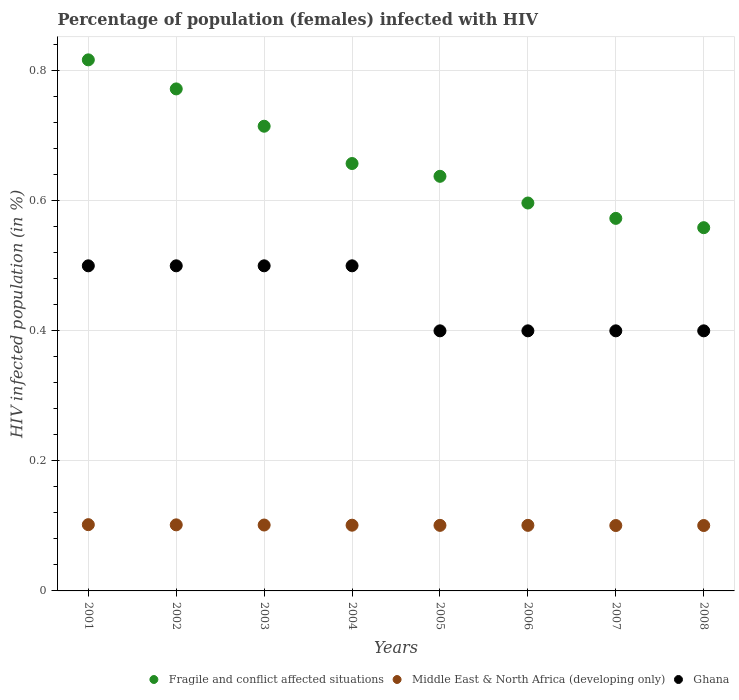What is the percentage of HIV infected female population in Ghana in 2003?
Your answer should be compact. 0.5. Across all years, what is the minimum percentage of HIV infected female population in Middle East & North Africa (developing only)?
Provide a succinct answer. 0.1. What is the total percentage of HIV infected female population in Middle East & North Africa (developing only) in the graph?
Keep it short and to the point. 0.81. What is the difference between the percentage of HIV infected female population in Middle East & North Africa (developing only) in 2003 and that in 2005?
Give a very brief answer. 0. What is the difference between the percentage of HIV infected female population in Middle East & North Africa (developing only) in 2002 and the percentage of HIV infected female population in Fragile and conflict affected situations in 2008?
Offer a terse response. -0.46. What is the average percentage of HIV infected female population in Fragile and conflict affected situations per year?
Offer a terse response. 0.67. In the year 2006, what is the difference between the percentage of HIV infected female population in Fragile and conflict affected situations and percentage of HIV infected female population in Middle East & North Africa (developing only)?
Keep it short and to the point. 0.5. In how many years, is the percentage of HIV infected female population in Middle East & North Africa (developing only) greater than 0.32 %?
Give a very brief answer. 0. What is the ratio of the percentage of HIV infected female population in Fragile and conflict affected situations in 2006 to that in 2008?
Your answer should be compact. 1.07. Is the percentage of HIV infected female population in Ghana in 2001 less than that in 2003?
Offer a terse response. No. What is the difference between the highest and the second highest percentage of HIV infected female population in Middle East & North Africa (developing only)?
Make the answer very short. 0. What is the difference between the highest and the lowest percentage of HIV infected female population in Middle East & North Africa (developing only)?
Make the answer very short. 0. In how many years, is the percentage of HIV infected female population in Fragile and conflict affected situations greater than the average percentage of HIV infected female population in Fragile and conflict affected situations taken over all years?
Ensure brevity in your answer.  3. Is the sum of the percentage of HIV infected female population in Fragile and conflict affected situations in 2005 and 2006 greater than the maximum percentage of HIV infected female population in Middle East & North Africa (developing only) across all years?
Make the answer very short. Yes. Does the percentage of HIV infected female population in Ghana monotonically increase over the years?
Your answer should be very brief. No. Is the percentage of HIV infected female population in Ghana strictly greater than the percentage of HIV infected female population in Middle East & North Africa (developing only) over the years?
Provide a succinct answer. Yes. Is the percentage of HIV infected female population in Fragile and conflict affected situations strictly less than the percentage of HIV infected female population in Middle East & North Africa (developing only) over the years?
Offer a very short reply. No. Does the graph contain any zero values?
Give a very brief answer. No. How many legend labels are there?
Make the answer very short. 3. How are the legend labels stacked?
Ensure brevity in your answer.  Horizontal. What is the title of the graph?
Offer a terse response. Percentage of population (females) infected with HIV. Does "Kazakhstan" appear as one of the legend labels in the graph?
Make the answer very short. No. What is the label or title of the Y-axis?
Your answer should be compact. HIV infected population (in %). What is the HIV infected population (in %) in Fragile and conflict affected situations in 2001?
Give a very brief answer. 0.82. What is the HIV infected population (in %) in Middle East & North Africa (developing only) in 2001?
Keep it short and to the point. 0.1. What is the HIV infected population (in %) of Ghana in 2001?
Offer a very short reply. 0.5. What is the HIV infected population (in %) of Fragile and conflict affected situations in 2002?
Ensure brevity in your answer.  0.77. What is the HIV infected population (in %) of Middle East & North Africa (developing only) in 2002?
Keep it short and to the point. 0.1. What is the HIV infected population (in %) in Fragile and conflict affected situations in 2003?
Your response must be concise. 0.71. What is the HIV infected population (in %) in Middle East & North Africa (developing only) in 2003?
Give a very brief answer. 0.1. What is the HIV infected population (in %) of Fragile and conflict affected situations in 2004?
Offer a terse response. 0.66. What is the HIV infected population (in %) in Middle East & North Africa (developing only) in 2004?
Provide a short and direct response. 0.1. What is the HIV infected population (in %) of Ghana in 2004?
Make the answer very short. 0.5. What is the HIV infected population (in %) of Fragile and conflict affected situations in 2005?
Your response must be concise. 0.64. What is the HIV infected population (in %) in Middle East & North Africa (developing only) in 2005?
Make the answer very short. 0.1. What is the HIV infected population (in %) in Ghana in 2005?
Ensure brevity in your answer.  0.4. What is the HIV infected population (in %) in Fragile and conflict affected situations in 2006?
Make the answer very short. 0.6. What is the HIV infected population (in %) in Middle East & North Africa (developing only) in 2006?
Your answer should be compact. 0.1. What is the HIV infected population (in %) of Fragile and conflict affected situations in 2007?
Make the answer very short. 0.57. What is the HIV infected population (in %) in Middle East & North Africa (developing only) in 2007?
Provide a short and direct response. 0.1. What is the HIV infected population (in %) of Ghana in 2007?
Make the answer very short. 0.4. What is the HIV infected population (in %) in Fragile and conflict affected situations in 2008?
Keep it short and to the point. 0.56. What is the HIV infected population (in %) of Middle East & North Africa (developing only) in 2008?
Offer a terse response. 0.1. Across all years, what is the maximum HIV infected population (in %) in Fragile and conflict affected situations?
Your answer should be compact. 0.82. Across all years, what is the maximum HIV infected population (in %) of Middle East & North Africa (developing only)?
Ensure brevity in your answer.  0.1. Across all years, what is the minimum HIV infected population (in %) of Fragile and conflict affected situations?
Your answer should be very brief. 0.56. Across all years, what is the minimum HIV infected population (in %) of Middle East & North Africa (developing only)?
Give a very brief answer. 0.1. Across all years, what is the minimum HIV infected population (in %) of Ghana?
Ensure brevity in your answer.  0.4. What is the total HIV infected population (in %) in Fragile and conflict affected situations in the graph?
Keep it short and to the point. 5.33. What is the total HIV infected population (in %) in Middle East & North Africa (developing only) in the graph?
Your response must be concise. 0.81. What is the difference between the HIV infected population (in %) of Fragile and conflict affected situations in 2001 and that in 2002?
Make the answer very short. 0.04. What is the difference between the HIV infected population (in %) of Middle East & North Africa (developing only) in 2001 and that in 2002?
Keep it short and to the point. 0. What is the difference between the HIV infected population (in %) in Fragile and conflict affected situations in 2001 and that in 2003?
Keep it short and to the point. 0.1. What is the difference between the HIV infected population (in %) in Fragile and conflict affected situations in 2001 and that in 2004?
Your response must be concise. 0.16. What is the difference between the HIV infected population (in %) of Middle East & North Africa (developing only) in 2001 and that in 2004?
Your answer should be compact. 0. What is the difference between the HIV infected population (in %) of Ghana in 2001 and that in 2004?
Your response must be concise. 0. What is the difference between the HIV infected population (in %) of Fragile and conflict affected situations in 2001 and that in 2005?
Offer a very short reply. 0.18. What is the difference between the HIV infected population (in %) of Middle East & North Africa (developing only) in 2001 and that in 2005?
Keep it short and to the point. 0. What is the difference between the HIV infected population (in %) of Fragile and conflict affected situations in 2001 and that in 2006?
Your answer should be very brief. 0.22. What is the difference between the HIV infected population (in %) in Middle East & North Africa (developing only) in 2001 and that in 2006?
Ensure brevity in your answer.  0. What is the difference between the HIV infected population (in %) in Ghana in 2001 and that in 2006?
Provide a succinct answer. 0.1. What is the difference between the HIV infected population (in %) of Fragile and conflict affected situations in 2001 and that in 2007?
Your answer should be compact. 0.24. What is the difference between the HIV infected population (in %) of Middle East & North Africa (developing only) in 2001 and that in 2007?
Your response must be concise. 0. What is the difference between the HIV infected population (in %) of Fragile and conflict affected situations in 2001 and that in 2008?
Give a very brief answer. 0.26. What is the difference between the HIV infected population (in %) of Middle East & North Africa (developing only) in 2001 and that in 2008?
Offer a very short reply. 0. What is the difference between the HIV infected population (in %) in Ghana in 2001 and that in 2008?
Provide a short and direct response. 0.1. What is the difference between the HIV infected population (in %) in Fragile and conflict affected situations in 2002 and that in 2003?
Offer a very short reply. 0.06. What is the difference between the HIV infected population (in %) of Middle East & North Africa (developing only) in 2002 and that in 2003?
Make the answer very short. 0. What is the difference between the HIV infected population (in %) in Fragile and conflict affected situations in 2002 and that in 2004?
Provide a succinct answer. 0.11. What is the difference between the HIV infected population (in %) in Middle East & North Africa (developing only) in 2002 and that in 2004?
Offer a terse response. 0. What is the difference between the HIV infected population (in %) in Fragile and conflict affected situations in 2002 and that in 2005?
Provide a short and direct response. 0.13. What is the difference between the HIV infected population (in %) in Middle East & North Africa (developing only) in 2002 and that in 2005?
Offer a terse response. 0. What is the difference between the HIV infected population (in %) in Fragile and conflict affected situations in 2002 and that in 2006?
Offer a very short reply. 0.18. What is the difference between the HIV infected population (in %) of Middle East & North Africa (developing only) in 2002 and that in 2006?
Ensure brevity in your answer.  0. What is the difference between the HIV infected population (in %) of Fragile and conflict affected situations in 2002 and that in 2007?
Provide a short and direct response. 0.2. What is the difference between the HIV infected population (in %) in Fragile and conflict affected situations in 2002 and that in 2008?
Keep it short and to the point. 0.21. What is the difference between the HIV infected population (in %) in Ghana in 2002 and that in 2008?
Offer a terse response. 0.1. What is the difference between the HIV infected population (in %) in Fragile and conflict affected situations in 2003 and that in 2004?
Your answer should be very brief. 0.06. What is the difference between the HIV infected population (in %) of Middle East & North Africa (developing only) in 2003 and that in 2004?
Offer a terse response. 0. What is the difference between the HIV infected population (in %) in Fragile and conflict affected situations in 2003 and that in 2005?
Provide a succinct answer. 0.08. What is the difference between the HIV infected population (in %) in Middle East & North Africa (developing only) in 2003 and that in 2005?
Your response must be concise. 0. What is the difference between the HIV infected population (in %) of Fragile and conflict affected situations in 2003 and that in 2006?
Your answer should be very brief. 0.12. What is the difference between the HIV infected population (in %) in Ghana in 2003 and that in 2006?
Provide a short and direct response. 0.1. What is the difference between the HIV infected population (in %) of Fragile and conflict affected situations in 2003 and that in 2007?
Offer a very short reply. 0.14. What is the difference between the HIV infected population (in %) of Middle East & North Africa (developing only) in 2003 and that in 2007?
Offer a terse response. 0. What is the difference between the HIV infected population (in %) of Fragile and conflict affected situations in 2003 and that in 2008?
Make the answer very short. 0.16. What is the difference between the HIV infected population (in %) of Middle East & North Africa (developing only) in 2003 and that in 2008?
Provide a succinct answer. 0. What is the difference between the HIV infected population (in %) in Fragile and conflict affected situations in 2004 and that in 2005?
Keep it short and to the point. 0.02. What is the difference between the HIV infected population (in %) in Middle East & North Africa (developing only) in 2004 and that in 2005?
Ensure brevity in your answer.  0. What is the difference between the HIV infected population (in %) of Ghana in 2004 and that in 2005?
Offer a very short reply. 0.1. What is the difference between the HIV infected population (in %) in Fragile and conflict affected situations in 2004 and that in 2006?
Keep it short and to the point. 0.06. What is the difference between the HIV infected population (in %) of Middle East & North Africa (developing only) in 2004 and that in 2006?
Provide a short and direct response. 0. What is the difference between the HIV infected population (in %) of Ghana in 2004 and that in 2006?
Give a very brief answer. 0.1. What is the difference between the HIV infected population (in %) of Fragile and conflict affected situations in 2004 and that in 2007?
Ensure brevity in your answer.  0.08. What is the difference between the HIV infected population (in %) in Middle East & North Africa (developing only) in 2004 and that in 2007?
Your answer should be very brief. 0. What is the difference between the HIV infected population (in %) of Ghana in 2004 and that in 2007?
Ensure brevity in your answer.  0.1. What is the difference between the HIV infected population (in %) in Fragile and conflict affected situations in 2004 and that in 2008?
Keep it short and to the point. 0.1. What is the difference between the HIV infected population (in %) of Ghana in 2004 and that in 2008?
Your answer should be very brief. 0.1. What is the difference between the HIV infected population (in %) of Fragile and conflict affected situations in 2005 and that in 2006?
Give a very brief answer. 0.04. What is the difference between the HIV infected population (in %) in Ghana in 2005 and that in 2006?
Make the answer very short. 0. What is the difference between the HIV infected population (in %) of Fragile and conflict affected situations in 2005 and that in 2007?
Provide a succinct answer. 0.06. What is the difference between the HIV infected population (in %) in Fragile and conflict affected situations in 2005 and that in 2008?
Provide a succinct answer. 0.08. What is the difference between the HIV infected population (in %) in Ghana in 2005 and that in 2008?
Make the answer very short. 0. What is the difference between the HIV infected population (in %) in Fragile and conflict affected situations in 2006 and that in 2007?
Ensure brevity in your answer.  0.02. What is the difference between the HIV infected population (in %) of Middle East & North Africa (developing only) in 2006 and that in 2007?
Ensure brevity in your answer.  0. What is the difference between the HIV infected population (in %) in Fragile and conflict affected situations in 2006 and that in 2008?
Ensure brevity in your answer.  0.04. What is the difference between the HIV infected population (in %) in Ghana in 2006 and that in 2008?
Make the answer very short. 0. What is the difference between the HIV infected population (in %) in Fragile and conflict affected situations in 2007 and that in 2008?
Make the answer very short. 0.01. What is the difference between the HIV infected population (in %) in Middle East & North Africa (developing only) in 2007 and that in 2008?
Your answer should be very brief. -0. What is the difference between the HIV infected population (in %) of Fragile and conflict affected situations in 2001 and the HIV infected population (in %) of Middle East & North Africa (developing only) in 2002?
Make the answer very short. 0.72. What is the difference between the HIV infected population (in %) in Fragile and conflict affected situations in 2001 and the HIV infected population (in %) in Ghana in 2002?
Keep it short and to the point. 0.32. What is the difference between the HIV infected population (in %) in Middle East & North Africa (developing only) in 2001 and the HIV infected population (in %) in Ghana in 2002?
Give a very brief answer. -0.4. What is the difference between the HIV infected population (in %) in Fragile and conflict affected situations in 2001 and the HIV infected population (in %) in Middle East & North Africa (developing only) in 2003?
Offer a very short reply. 0.72. What is the difference between the HIV infected population (in %) of Fragile and conflict affected situations in 2001 and the HIV infected population (in %) of Ghana in 2003?
Provide a succinct answer. 0.32. What is the difference between the HIV infected population (in %) in Middle East & North Africa (developing only) in 2001 and the HIV infected population (in %) in Ghana in 2003?
Offer a terse response. -0.4. What is the difference between the HIV infected population (in %) of Fragile and conflict affected situations in 2001 and the HIV infected population (in %) of Middle East & North Africa (developing only) in 2004?
Make the answer very short. 0.72. What is the difference between the HIV infected population (in %) in Fragile and conflict affected situations in 2001 and the HIV infected population (in %) in Ghana in 2004?
Offer a very short reply. 0.32. What is the difference between the HIV infected population (in %) in Middle East & North Africa (developing only) in 2001 and the HIV infected population (in %) in Ghana in 2004?
Give a very brief answer. -0.4. What is the difference between the HIV infected population (in %) of Fragile and conflict affected situations in 2001 and the HIV infected population (in %) of Middle East & North Africa (developing only) in 2005?
Your answer should be very brief. 0.72. What is the difference between the HIV infected population (in %) in Fragile and conflict affected situations in 2001 and the HIV infected population (in %) in Ghana in 2005?
Your answer should be compact. 0.42. What is the difference between the HIV infected population (in %) in Middle East & North Africa (developing only) in 2001 and the HIV infected population (in %) in Ghana in 2005?
Keep it short and to the point. -0.3. What is the difference between the HIV infected population (in %) of Fragile and conflict affected situations in 2001 and the HIV infected population (in %) of Middle East & North Africa (developing only) in 2006?
Offer a very short reply. 0.72. What is the difference between the HIV infected population (in %) in Fragile and conflict affected situations in 2001 and the HIV infected population (in %) in Ghana in 2006?
Provide a succinct answer. 0.42. What is the difference between the HIV infected population (in %) in Middle East & North Africa (developing only) in 2001 and the HIV infected population (in %) in Ghana in 2006?
Provide a short and direct response. -0.3. What is the difference between the HIV infected population (in %) in Fragile and conflict affected situations in 2001 and the HIV infected population (in %) in Middle East & North Africa (developing only) in 2007?
Provide a short and direct response. 0.72. What is the difference between the HIV infected population (in %) in Fragile and conflict affected situations in 2001 and the HIV infected population (in %) in Ghana in 2007?
Your answer should be compact. 0.42. What is the difference between the HIV infected population (in %) of Middle East & North Africa (developing only) in 2001 and the HIV infected population (in %) of Ghana in 2007?
Your answer should be compact. -0.3. What is the difference between the HIV infected population (in %) in Fragile and conflict affected situations in 2001 and the HIV infected population (in %) in Middle East & North Africa (developing only) in 2008?
Ensure brevity in your answer.  0.72. What is the difference between the HIV infected population (in %) in Fragile and conflict affected situations in 2001 and the HIV infected population (in %) in Ghana in 2008?
Provide a short and direct response. 0.42. What is the difference between the HIV infected population (in %) of Middle East & North Africa (developing only) in 2001 and the HIV infected population (in %) of Ghana in 2008?
Offer a terse response. -0.3. What is the difference between the HIV infected population (in %) in Fragile and conflict affected situations in 2002 and the HIV infected population (in %) in Middle East & North Africa (developing only) in 2003?
Provide a short and direct response. 0.67. What is the difference between the HIV infected population (in %) of Fragile and conflict affected situations in 2002 and the HIV infected population (in %) of Ghana in 2003?
Ensure brevity in your answer.  0.27. What is the difference between the HIV infected population (in %) of Middle East & North Africa (developing only) in 2002 and the HIV infected population (in %) of Ghana in 2003?
Your answer should be compact. -0.4. What is the difference between the HIV infected population (in %) in Fragile and conflict affected situations in 2002 and the HIV infected population (in %) in Middle East & North Africa (developing only) in 2004?
Give a very brief answer. 0.67. What is the difference between the HIV infected population (in %) of Fragile and conflict affected situations in 2002 and the HIV infected population (in %) of Ghana in 2004?
Offer a very short reply. 0.27. What is the difference between the HIV infected population (in %) in Middle East & North Africa (developing only) in 2002 and the HIV infected population (in %) in Ghana in 2004?
Offer a terse response. -0.4. What is the difference between the HIV infected population (in %) of Fragile and conflict affected situations in 2002 and the HIV infected population (in %) of Middle East & North Africa (developing only) in 2005?
Your answer should be compact. 0.67. What is the difference between the HIV infected population (in %) in Fragile and conflict affected situations in 2002 and the HIV infected population (in %) in Ghana in 2005?
Your answer should be very brief. 0.37. What is the difference between the HIV infected population (in %) of Middle East & North Africa (developing only) in 2002 and the HIV infected population (in %) of Ghana in 2005?
Keep it short and to the point. -0.3. What is the difference between the HIV infected population (in %) in Fragile and conflict affected situations in 2002 and the HIV infected population (in %) in Middle East & North Africa (developing only) in 2006?
Your answer should be very brief. 0.67. What is the difference between the HIV infected population (in %) of Fragile and conflict affected situations in 2002 and the HIV infected population (in %) of Ghana in 2006?
Provide a short and direct response. 0.37. What is the difference between the HIV infected population (in %) of Middle East & North Africa (developing only) in 2002 and the HIV infected population (in %) of Ghana in 2006?
Give a very brief answer. -0.3. What is the difference between the HIV infected population (in %) in Fragile and conflict affected situations in 2002 and the HIV infected population (in %) in Middle East & North Africa (developing only) in 2007?
Make the answer very short. 0.67. What is the difference between the HIV infected population (in %) in Fragile and conflict affected situations in 2002 and the HIV infected population (in %) in Ghana in 2007?
Provide a succinct answer. 0.37. What is the difference between the HIV infected population (in %) of Middle East & North Africa (developing only) in 2002 and the HIV infected population (in %) of Ghana in 2007?
Offer a terse response. -0.3. What is the difference between the HIV infected population (in %) of Fragile and conflict affected situations in 2002 and the HIV infected population (in %) of Middle East & North Africa (developing only) in 2008?
Provide a succinct answer. 0.67. What is the difference between the HIV infected population (in %) in Fragile and conflict affected situations in 2002 and the HIV infected population (in %) in Ghana in 2008?
Your response must be concise. 0.37. What is the difference between the HIV infected population (in %) in Middle East & North Africa (developing only) in 2002 and the HIV infected population (in %) in Ghana in 2008?
Your answer should be very brief. -0.3. What is the difference between the HIV infected population (in %) in Fragile and conflict affected situations in 2003 and the HIV infected population (in %) in Middle East & North Africa (developing only) in 2004?
Keep it short and to the point. 0.61. What is the difference between the HIV infected population (in %) of Fragile and conflict affected situations in 2003 and the HIV infected population (in %) of Ghana in 2004?
Keep it short and to the point. 0.21. What is the difference between the HIV infected population (in %) in Middle East & North Africa (developing only) in 2003 and the HIV infected population (in %) in Ghana in 2004?
Make the answer very short. -0.4. What is the difference between the HIV infected population (in %) in Fragile and conflict affected situations in 2003 and the HIV infected population (in %) in Middle East & North Africa (developing only) in 2005?
Give a very brief answer. 0.61. What is the difference between the HIV infected population (in %) in Fragile and conflict affected situations in 2003 and the HIV infected population (in %) in Ghana in 2005?
Offer a very short reply. 0.31. What is the difference between the HIV infected population (in %) in Middle East & North Africa (developing only) in 2003 and the HIV infected population (in %) in Ghana in 2005?
Offer a terse response. -0.3. What is the difference between the HIV infected population (in %) in Fragile and conflict affected situations in 2003 and the HIV infected population (in %) in Middle East & North Africa (developing only) in 2006?
Your answer should be very brief. 0.61. What is the difference between the HIV infected population (in %) of Fragile and conflict affected situations in 2003 and the HIV infected population (in %) of Ghana in 2006?
Offer a terse response. 0.31. What is the difference between the HIV infected population (in %) of Middle East & North Africa (developing only) in 2003 and the HIV infected population (in %) of Ghana in 2006?
Your answer should be very brief. -0.3. What is the difference between the HIV infected population (in %) in Fragile and conflict affected situations in 2003 and the HIV infected population (in %) in Middle East & North Africa (developing only) in 2007?
Keep it short and to the point. 0.61. What is the difference between the HIV infected population (in %) of Fragile and conflict affected situations in 2003 and the HIV infected population (in %) of Ghana in 2007?
Your answer should be compact. 0.31. What is the difference between the HIV infected population (in %) in Middle East & North Africa (developing only) in 2003 and the HIV infected population (in %) in Ghana in 2007?
Provide a short and direct response. -0.3. What is the difference between the HIV infected population (in %) of Fragile and conflict affected situations in 2003 and the HIV infected population (in %) of Middle East & North Africa (developing only) in 2008?
Your response must be concise. 0.61. What is the difference between the HIV infected population (in %) in Fragile and conflict affected situations in 2003 and the HIV infected population (in %) in Ghana in 2008?
Your answer should be compact. 0.31. What is the difference between the HIV infected population (in %) of Middle East & North Africa (developing only) in 2003 and the HIV infected population (in %) of Ghana in 2008?
Offer a very short reply. -0.3. What is the difference between the HIV infected population (in %) in Fragile and conflict affected situations in 2004 and the HIV infected population (in %) in Middle East & North Africa (developing only) in 2005?
Provide a short and direct response. 0.56. What is the difference between the HIV infected population (in %) in Fragile and conflict affected situations in 2004 and the HIV infected population (in %) in Ghana in 2005?
Give a very brief answer. 0.26. What is the difference between the HIV infected population (in %) of Middle East & North Africa (developing only) in 2004 and the HIV infected population (in %) of Ghana in 2005?
Keep it short and to the point. -0.3. What is the difference between the HIV infected population (in %) of Fragile and conflict affected situations in 2004 and the HIV infected population (in %) of Middle East & North Africa (developing only) in 2006?
Make the answer very short. 0.56. What is the difference between the HIV infected population (in %) of Fragile and conflict affected situations in 2004 and the HIV infected population (in %) of Ghana in 2006?
Keep it short and to the point. 0.26. What is the difference between the HIV infected population (in %) of Middle East & North Africa (developing only) in 2004 and the HIV infected population (in %) of Ghana in 2006?
Keep it short and to the point. -0.3. What is the difference between the HIV infected population (in %) of Fragile and conflict affected situations in 2004 and the HIV infected population (in %) of Middle East & North Africa (developing only) in 2007?
Give a very brief answer. 0.56. What is the difference between the HIV infected population (in %) of Fragile and conflict affected situations in 2004 and the HIV infected population (in %) of Ghana in 2007?
Offer a very short reply. 0.26. What is the difference between the HIV infected population (in %) of Middle East & North Africa (developing only) in 2004 and the HIV infected population (in %) of Ghana in 2007?
Your answer should be compact. -0.3. What is the difference between the HIV infected population (in %) of Fragile and conflict affected situations in 2004 and the HIV infected population (in %) of Middle East & North Africa (developing only) in 2008?
Provide a short and direct response. 0.56. What is the difference between the HIV infected population (in %) in Fragile and conflict affected situations in 2004 and the HIV infected population (in %) in Ghana in 2008?
Give a very brief answer. 0.26. What is the difference between the HIV infected population (in %) of Middle East & North Africa (developing only) in 2004 and the HIV infected population (in %) of Ghana in 2008?
Your answer should be compact. -0.3. What is the difference between the HIV infected population (in %) of Fragile and conflict affected situations in 2005 and the HIV infected population (in %) of Middle East & North Africa (developing only) in 2006?
Ensure brevity in your answer.  0.54. What is the difference between the HIV infected population (in %) in Fragile and conflict affected situations in 2005 and the HIV infected population (in %) in Ghana in 2006?
Keep it short and to the point. 0.24. What is the difference between the HIV infected population (in %) of Middle East & North Africa (developing only) in 2005 and the HIV infected population (in %) of Ghana in 2006?
Offer a very short reply. -0.3. What is the difference between the HIV infected population (in %) in Fragile and conflict affected situations in 2005 and the HIV infected population (in %) in Middle East & North Africa (developing only) in 2007?
Keep it short and to the point. 0.54. What is the difference between the HIV infected population (in %) of Fragile and conflict affected situations in 2005 and the HIV infected population (in %) of Ghana in 2007?
Offer a very short reply. 0.24. What is the difference between the HIV infected population (in %) of Middle East & North Africa (developing only) in 2005 and the HIV infected population (in %) of Ghana in 2007?
Provide a short and direct response. -0.3. What is the difference between the HIV infected population (in %) of Fragile and conflict affected situations in 2005 and the HIV infected population (in %) of Middle East & North Africa (developing only) in 2008?
Ensure brevity in your answer.  0.54. What is the difference between the HIV infected population (in %) in Fragile and conflict affected situations in 2005 and the HIV infected population (in %) in Ghana in 2008?
Make the answer very short. 0.24. What is the difference between the HIV infected population (in %) of Middle East & North Africa (developing only) in 2005 and the HIV infected population (in %) of Ghana in 2008?
Offer a terse response. -0.3. What is the difference between the HIV infected population (in %) of Fragile and conflict affected situations in 2006 and the HIV infected population (in %) of Middle East & North Africa (developing only) in 2007?
Ensure brevity in your answer.  0.5. What is the difference between the HIV infected population (in %) of Fragile and conflict affected situations in 2006 and the HIV infected population (in %) of Ghana in 2007?
Provide a succinct answer. 0.2. What is the difference between the HIV infected population (in %) in Middle East & North Africa (developing only) in 2006 and the HIV infected population (in %) in Ghana in 2007?
Provide a succinct answer. -0.3. What is the difference between the HIV infected population (in %) of Fragile and conflict affected situations in 2006 and the HIV infected population (in %) of Middle East & North Africa (developing only) in 2008?
Your answer should be compact. 0.5. What is the difference between the HIV infected population (in %) of Fragile and conflict affected situations in 2006 and the HIV infected population (in %) of Ghana in 2008?
Keep it short and to the point. 0.2. What is the difference between the HIV infected population (in %) of Middle East & North Africa (developing only) in 2006 and the HIV infected population (in %) of Ghana in 2008?
Provide a short and direct response. -0.3. What is the difference between the HIV infected population (in %) of Fragile and conflict affected situations in 2007 and the HIV infected population (in %) of Middle East & North Africa (developing only) in 2008?
Provide a short and direct response. 0.47. What is the difference between the HIV infected population (in %) in Fragile and conflict affected situations in 2007 and the HIV infected population (in %) in Ghana in 2008?
Give a very brief answer. 0.17. What is the difference between the HIV infected population (in %) in Middle East & North Africa (developing only) in 2007 and the HIV infected population (in %) in Ghana in 2008?
Provide a succinct answer. -0.3. What is the average HIV infected population (in %) of Fragile and conflict affected situations per year?
Offer a terse response. 0.67. What is the average HIV infected population (in %) in Middle East & North Africa (developing only) per year?
Offer a very short reply. 0.1. What is the average HIV infected population (in %) of Ghana per year?
Ensure brevity in your answer.  0.45. In the year 2001, what is the difference between the HIV infected population (in %) in Fragile and conflict affected situations and HIV infected population (in %) in Middle East & North Africa (developing only)?
Give a very brief answer. 0.71. In the year 2001, what is the difference between the HIV infected population (in %) in Fragile and conflict affected situations and HIV infected population (in %) in Ghana?
Offer a very short reply. 0.32. In the year 2001, what is the difference between the HIV infected population (in %) in Middle East & North Africa (developing only) and HIV infected population (in %) in Ghana?
Make the answer very short. -0.4. In the year 2002, what is the difference between the HIV infected population (in %) in Fragile and conflict affected situations and HIV infected population (in %) in Middle East & North Africa (developing only)?
Make the answer very short. 0.67. In the year 2002, what is the difference between the HIV infected population (in %) in Fragile and conflict affected situations and HIV infected population (in %) in Ghana?
Provide a succinct answer. 0.27. In the year 2002, what is the difference between the HIV infected population (in %) of Middle East & North Africa (developing only) and HIV infected population (in %) of Ghana?
Your answer should be very brief. -0.4. In the year 2003, what is the difference between the HIV infected population (in %) of Fragile and conflict affected situations and HIV infected population (in %) of Middle East & North Africa (developing only)?
Provide a short and direct response. 0.61. In the year 2003, what is the difference between the HIV infected population (in %) in Fragile and conflict affected situations and HIV infected population (in %) in Ghana?
Your response must be concise. 0.21. In the year 2003, what is the difference between the HIV infected population (in %) of Middle East & North Africa (developing only) and HIV infected population (in %) of Ghana?
Make the answer very short. -0.4. In the year 2004, what is the difference between the HIV infected population (in %) in Fragile and conflict affected situations and HIV infected population (in %) in Middle East & North Africa (developing only)?
Your answer should be very brief. 0.56. In the year 2004, what is the difference between the HIV infected population (in %) in Fragile and conflict affected situations and HIV infected population (in %) in Ghana?
Provide a succinct answer. 0.16. In the year 2004, what is the difference between the HIV infected population (in %) in Middle East & North Africa (developing only) and HIV infected population (in %) in Ghana?
Keep it short and to the point. -0.4. In the year 2005, what is the difference between the HIV infected population (in %) in Fragile and conflict affected situations and HIV infected population (in %) in Middle East & North Africa (developing only)?
Make the answer very short. 0.54. In the year 2005, what is the difference between the HIV infected population (in %) in Fragile and conflict affected situations and HIV infected population (in %) in Ghana?
Offer a very short reply. 0.24. In the year 2005, what is the difference between the HIV infected population (in %) of Middle East & North Africa (developing only) and HIV infected population (in %) of Ghana?
Your answer should be very brief. -0.3. In the year 2006, what is the difference between the HIV infected population (in %) of Fragile and conflict affected situations and HIV infected population (in %) of Middle East & North Africa (developing only)?
Your response must be concise. 0.5. In the year 2006, what is the difference between the HIV infected population (in %) of Fragile and conflict affected situations and HIV infected population (in %) of Ghana?
Keep it short and to the point. 0.2. In the year 2006, what is the difference between the HIV infected population (in %) of Middle East & North Africa (developing only) and HIV infected population (in %) of Ghana?
Offer a terse response. -0.3. In the year 2007, what is the difference between the HIV infected population (in %) of Fragile and conflict affected situations and HIV infected population (in %) of Middle East & North Africa (developing only)?
Keep it short and to the point. 0.47. In the year 2007, what is the difference between the HIV infected population (in %) of Fragile and conflict affected situations and HIV infected population (in %) of Ghana?
Your answer should be very brief. 0.17. In the year 2007, what is the difference between the HIV infected population (in %) in Middle East & North Africa (developing only) and HIV infected population (in %) in Ghana?
Offer a terse response. -0.3. In the year 2008, what is the difference between the HIV infected population (in %) in Fragile and conflict affected situations and HIV infected population (in %) in Middle East & North Africa (developing only)?
Provide a short and direct response. 0.46. In the year 2008, what is the difference between the HIV infected population (in %) of Fragile and conflict affected situations and HIV infected population (in %) of Ghana?
Offer a terse response. 0.16. In the year 2008, what is the difference between the HIV infected population (in %) of Middle East & North Africa (developing only) and HIV infected population (in %) of Ghana?
Give a very brief answer. -0.3. What is the ratio of the HIV infected population (in %) in Fragile and conflict affected situations in 2001 to that in 2002?
Keep it short and to the point. 1.06. What is the ratio of the HIV infected population (in %) of Fragile and conflict affected situations in 2001 to that in 2003?
Your answer should be very brief. 1.14. What is the ratio of the HIV infected population (in %) of Middle East & North Africa (developing only) in 2001 to that in 2003?
Provide a succinct answer. 1.01. What is the ratio of the HIV infected population (in %) of Ghana in 2001 to that in 2003?
Provide a short and direct response. 1. What is the ratio of the HIV infected population (in %) in Fragile and conflict affected situations in 2001 to that in 2004?
Give a very brief answer. 1.24. What is the ratio of the HIV infected population (in %) of Ghana in 2001 to that in 2004?
Make the answer very short. 1. What is the ratio of the HIV infected population (in %) of Fragile and conflict affected situations in 2001 to that in 2005?
Your answer should be very brief. 1.28. What is the ratio of the HIV infected population (in %) of Middle East & North Africa (developing only) in 2001 to that in 2005?
Give a very brief answer. 1.01. What is the ratio of the HIV infected population (in %) in Ghana in 2001 to that in 2005?
Give a very brief answer. 1.25. What is the ratio of the HIV infected population (in %) of Fragile and conflict affected situations in 2001 to that in 2006?
Offer a terse response. 1.37. What is the ratio of the HIV infected population (in %) of Middle East & North Africa (developing only) in 2001 to that in 2006?
Offer a terse response. 1.01. What is the ratio of the HIV infected population (in %) in Ghana in 2001 to that in 2006?
Provide a succinct answer. 1.25. What is the ratio of the HIV infected population (in %) in Fragile and conflict affected situations in 2001 to that in 2007?
Ensure brevity in your answer.  1.43. What is the ratio of the HIV infected population (in %) in Middle East & North Africa (developing only) in 2001 to that in 2007?
Your answer should be compact. 1.01. What is the ratio of the HIV infected population (in %) of Fragile and conflict affected situations in 2001 to that in 2008?
Offer a terse response. 1.46. What is the ratio of the HIV infected population (in %) in Ghana in 2001 to that in 2008?
Offer a very short reply. 1.25. What is the ratio of the HIV infected population (in %) in Fragile and conflict affected situations in 2002 to that in 2003?
Offer a very short reply. 1.08. What is the ratio of the HIV infected population (in %) in Middle East & North Africa (developing only) in 2002 to that in 2003?
Offer a very short reply. 1. What is the ratio of the HIV infected population (in %) of Fragile and conflict affected situations in 2002 to that in 2004?
Offer a terse response. 1.17. What is the ratio of the HIV infected population (in %) in Middle East & North Africa (developing only) in 2002 to that in 2004?
Provide a short and direct response. 1.01. What is the ratio of the HIV infected population (in %) of Fragile and conflict affected situations in 2002 to that in 2005?
Offer a very short reply. 1.21. What is the ratio of the HIV infected population (in %) in Middle East & North Africa (developing only) in 2002 to that in 2005?
Keep it short and to the point. 1.01. What is the ratio of the HIV infected population (in %) in Fragile and conflict affected situations in 2002 to that in 2006?
Provide a succinct answer. 1.29. What is the ratio of the HIV infected population (in %) in Middle East & North Africa (developing only) in 2002 to that in 2006?
Make the answer very short. 1.01. What is the ratio of the HIV infected population (in %) of Fragile and conflict affected situations in 2002 to that in 2007?
Provide a succinct answer. 1.35. What is the ratio of the HIV infected population (in %) in Middle East & North Africa (developing only) in 2002 to that in 2007?
Give a very brief answer. 1.01. What is the ratio of the HIV infected population (in %) of Fragile and conflict affected situations in 2002 to that in 2008?
Your answer should be compact. 1.38. What is the ratio of the HIV infected population (in %) of Middle East & North Africa (developing only) in 2002 to that in 2008?
Your answer should be compact. 1.01. What is the ratio of the HIV infected population (in %) in Ghana in 2002 to that in 2008?
Your response must be concise. 1.25. What is the ratio of the HIV infected population (in %) of Fragile and conflict affected situations in 2003 to that in 2004?
Offer a terse response. 1.09. What is the ratio of the HIV infected population (in %) in Fragile and conflict affected situations in 2003 to that in 2005?
Provide a succinct answer. 1.12. What is the ratio of the HIV infected population (in %) in Middle East & North Africa (developing only) in 2003 to that in 2005?
Your answer should be compact. 1.01. What is the ratio of the HIV infected population (in %) in Fragile and conflict affected situations in 2003 to that in 2006?
Your answer should be compact. 1.2. What is the ratio of the HIV infected population (in %) of Fragile and conflict affected situations in 2003 to that in 2007?
Provide a short and direct response. 1.25. What is the ratio of the HIV infected population (in %) in Middle East & North Africa (developing only) in 2003 to that in 2007?
Keep it short and to the point. 1.01. What is the ratio of the HIV infected population (in %) in Fragile and conflict affected situations in 2003 to that in 2008?
Make the answer very short. 1.28. What is the ratio of the HIV infected population (in %) in Middle East & North Africa (developing only) in 2003 to that in 2008?
Your answer should be compact. 1.01. What is the ratio of the HIV infected population (in %) of Fragile and conflict affected situations in 2004 to that in 2005?
Keep it short and to the point. 1.03. What is the ratio of the HIV infected population (in %) in Middle East & North Africa (developing only) in 2004 to that in 2005?
Make the answer very short. 1. What is the ratio of the HIV infected population (in %) of Ghana in 2004 to that in 2005?
Offer a terse response. 1.25. What is the ratio of the HIV infected population (in %) of Fragile and conflict affected situations in 2004 to that in 2006?
Offer a very short reply. 1.1. What is the ratio of the HIV infected population (in %) in Fragile and conflict affected situations in 2004 to that in 2007?
Keep it short and to the point. 1.15. What is the ratio of the HIV infected population (in %) of Middle East & North Africa (developing only) in 2004 to that in 2007?
Provide a succinct answer. 1.01. What is the ratio of the HIV infected population (in %) of Ghana in 2004 to that in 2007?
Make the answer very short. 1.25. What is the ratio of the HIV infected population (in %) of Fragile and conflict affected situations in 2004 to that in 2008?
Ensure brevity in your answer.  1.18. What is the ratio of the HIV infected population (in %) in Ghana in 2004 to that in 2008?
Offer a terse response. 1.25. What is the ratio of the HIV infected population (in %) in Fragile and conflict affected situations in 2005 to that in 2006?
Provide a short and direct response. 1.07. What is the ratio of the HIV infected population (in %) in Fragile and conflict affected situations in 2005 to that in 2007?
Your answer should be compact. 1.11. What is the ratio of the HIV infected population (in %) of Ghana in 2005 to that in 2007?
Offer a very short reply. 1. What is the ratio of the HIV infected population (in %) of Fragile and conflict affected situations in 2005 to that in 2008?
Your answer should be very brief. 1.14. What is the ratio of the HIV infected population (in %) of Fragile and conflict affected situations in 2006 to that in 2007?
Keep it short and to the point. 1.04. What is the ratio of the HIV infected population (in %) of Fragile and conflict affected situations in 2006 to that in 2008?
Provide a succinct answer. 1.07. What is the ratio of the HIV infected population (in %) of Middle East & North Africa (developing only) in 2006 to that in 2008?
Your response must be concise. 1. What is the ratio of the HIV infected population (in %) in Ghana in 2006 to that in 2008?
Make the answer very short. 1. What is the ratio of the HIV infected population (in %) of Fragile and conflict affected situations in 2007 to that in 2008?
Offer a terse response. 1.03. What is the difference between the highest and the second highest HIV infected population (in %) of Fragile and conflict affected situations?
Your response must be concise. 0.04. What is the difference between the highest and the second highest HIV infected population (in %) in Middle East & North Africa (developing only)?
Your answer should be very brief. 0. What is the difference between the highest and the lowest HIV infected population (in %) of Fragile and conflict affected situations?
Provide a succinct answer. 0.26. What is the difference between the highest and the lowest HIV infected population (in %) of Middle East & North Africa (developing only)?
Provide a short and direct response. 0. What is the difference between the highest and the lowest HIV infected population (in %) in Ghana?
Keep it short and to the point. 0.1. 